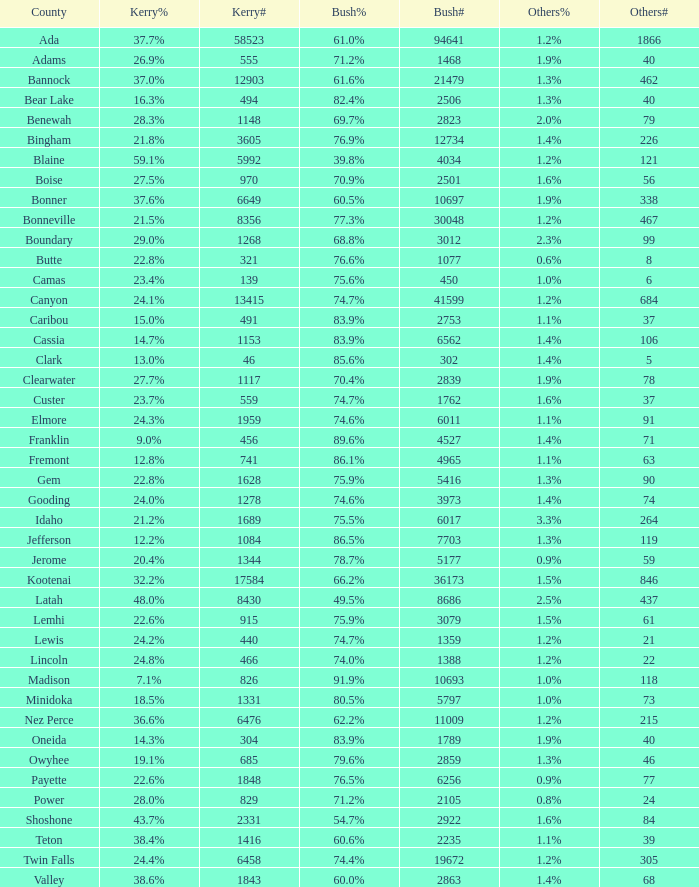6%? 60.5%. 